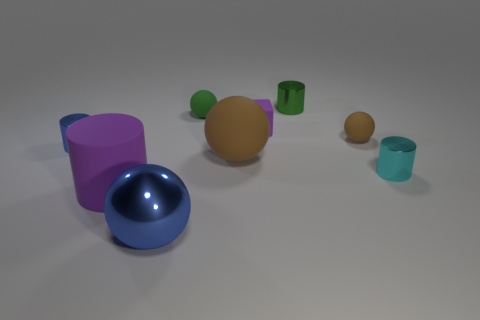There is a small green thing that is the same shape as the big purple thing; what material is it?
Offer a terse response. Metal. There is a tiny cylinder to the left of the tiny purple rubber block; is it the same color as the metallic ball?
Make the answer very short. Yes. The ball that is behind the large brown rubber sphere and to the left of the purple rubber block is what color?
Offer a very short reply. Green. What is the material of the cylinder in front of the cyan cylinder?
Provide a short and direct response. Rubber. The cyan thing is what size?
Provide a short and direct response. Small. How many blue things are either big rubber spheres or small cylinders?
Offer a very short reply. 1. How big is the purple matte thing on the left side of the large blue metallic ball that is in front of the tiny purple cube?
Provide a short and direct response. Large. Does the big shiny thing have the same color as the small shiny thing that is on the left side of the blue sphere?
Offer a very short reply. Yes. How many other objects are the same material as the small brown thing?
Offer a very short reply. 4. The tiny brown thing that is made of the same material as the green ball is what shape?
Make the answer very short. Sphere. 